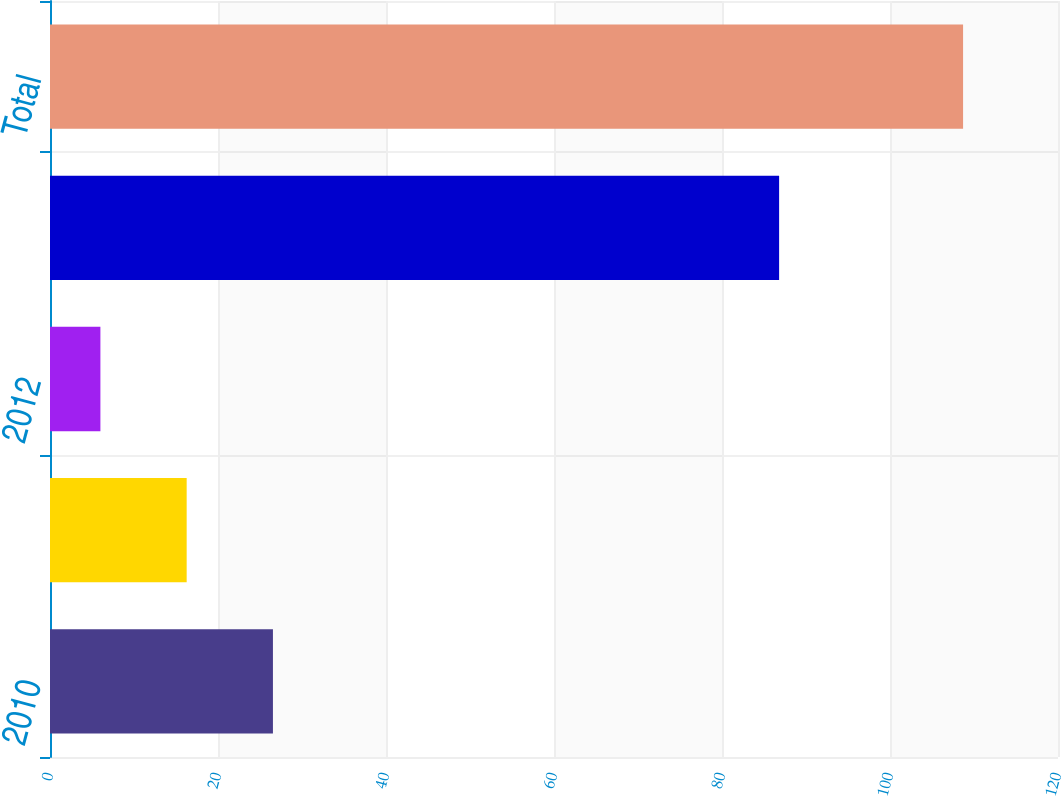Convert chart to OTSL. <chart><loc_0><loc_0><loc_500><loc_500><bar_chart><fcel>2010<fcel>2011<fcel>2012<fcel>2013-2034<fcel>Total<nl><fcel>26.54<fcel>16.27<fcel>6<fcel>86.8<fcel>108.7<nl></chart> 